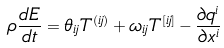Convert formula to latex. <formula><loc_0><loc_0><loc_500><loc_500>\rho \frac { d E } { d t } = \theta _ { i j } T ^ { ( i j ) } + \omega _ { i j } T ^ { [ i j ] } - \frac { \partial q ^ { i } } { \partial x ^ { i } }</formula> 